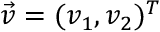<formula> <loc_0><loc_0><loc_500><loc_500>\vec { v } = ( v _ { 1 } , v _ { 2 } ) ^ { T }</formula> 